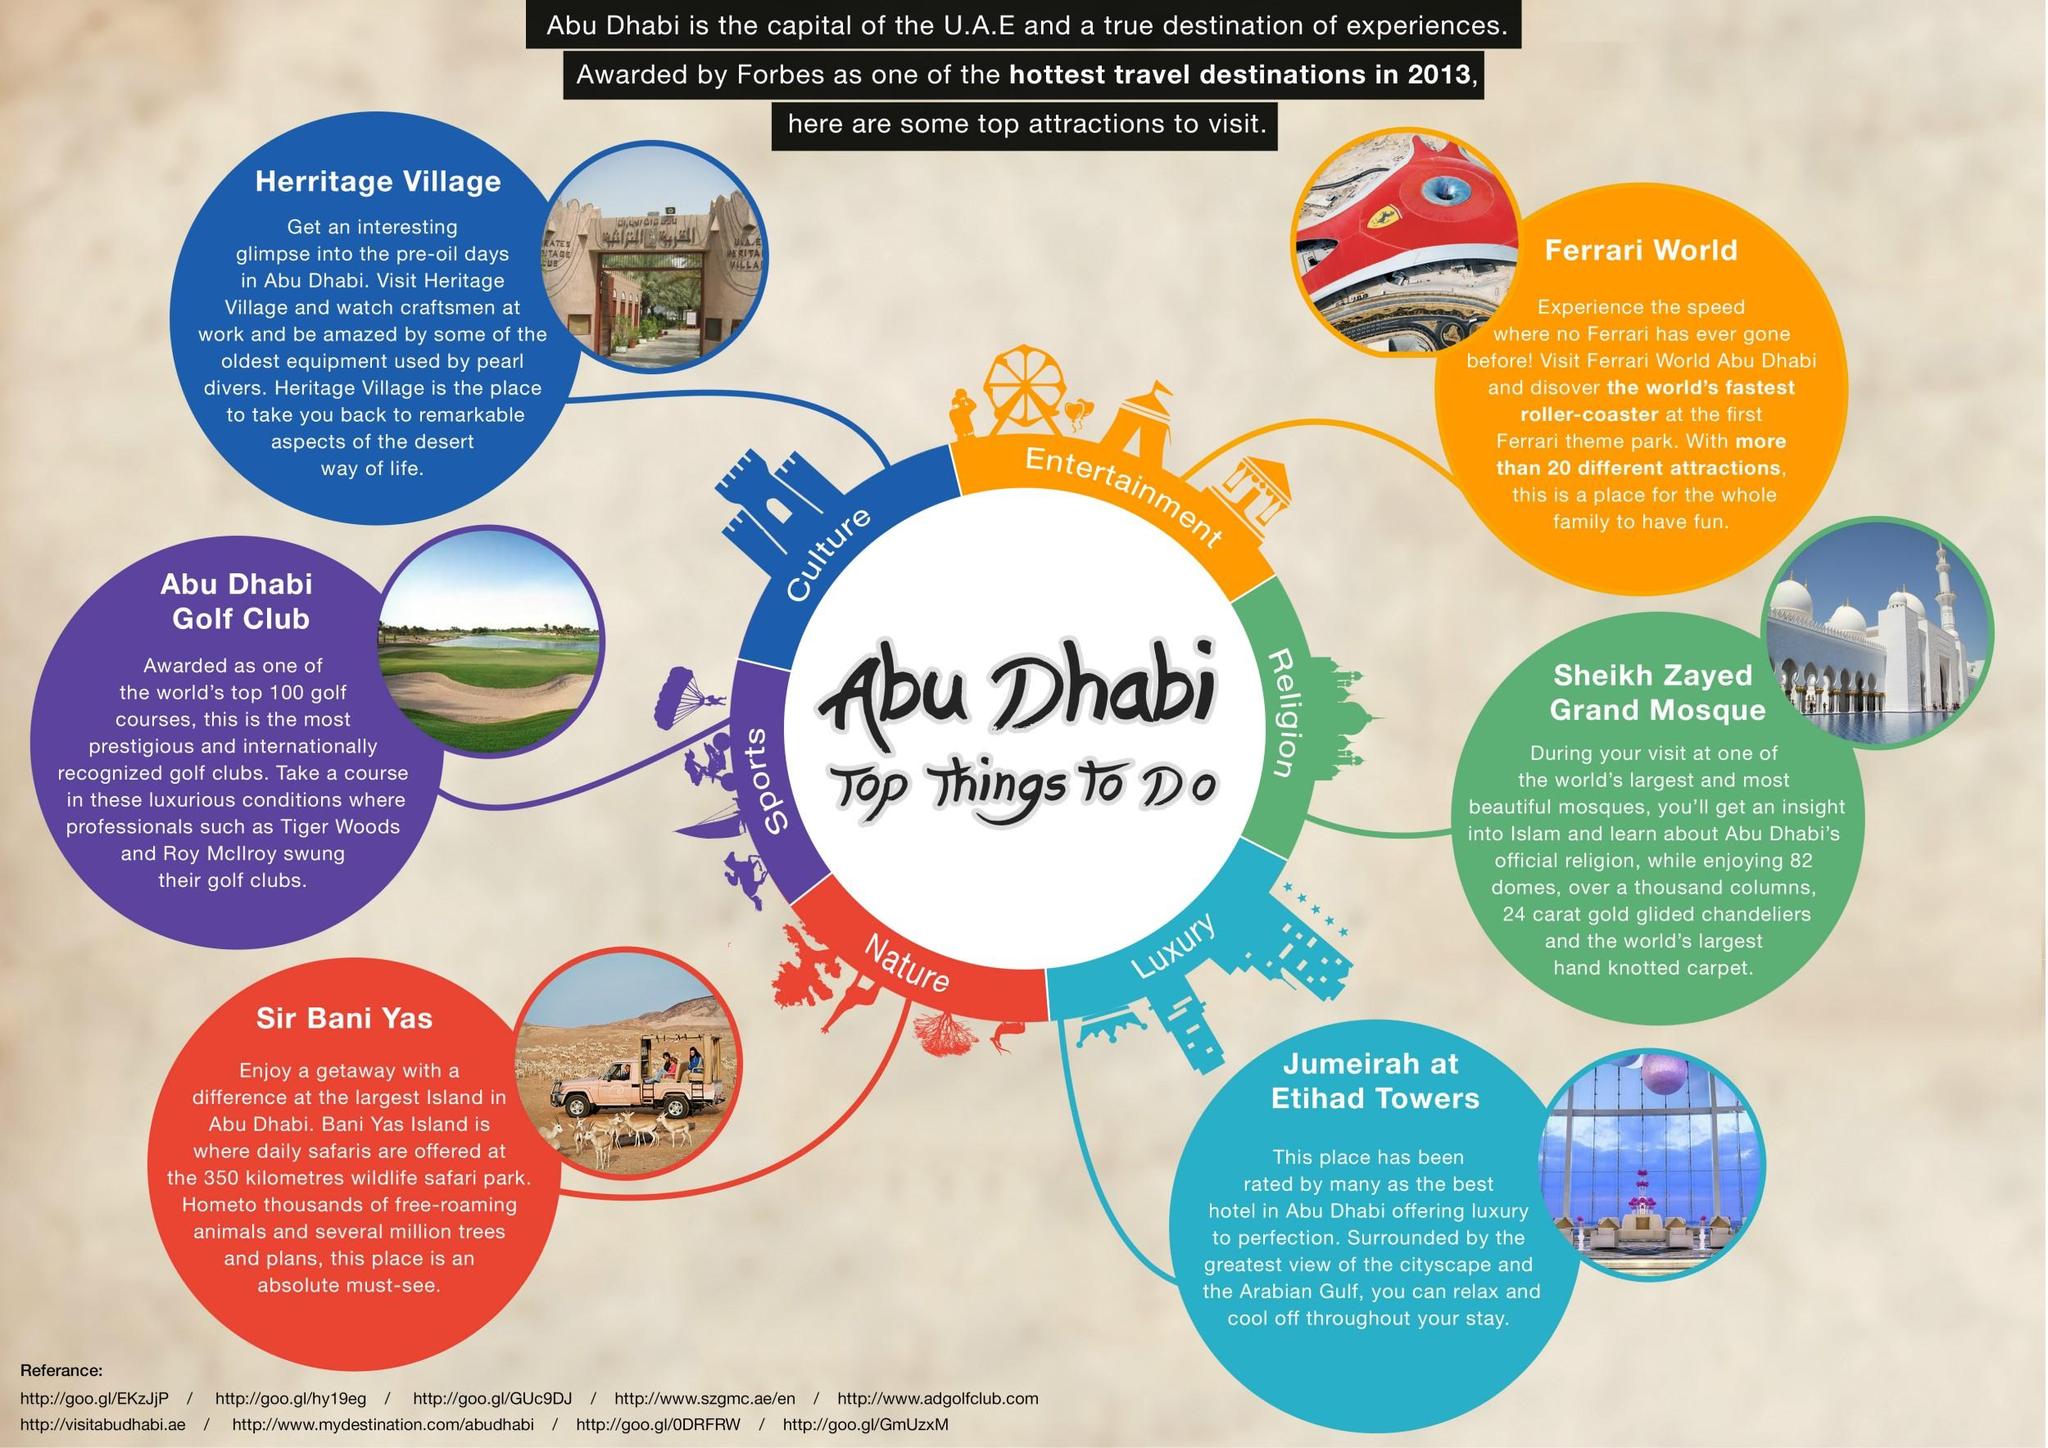Mention a couple of crucial points in this snapshot. There are a total of 6 destinations that can be visited in Abu Dhabi. 